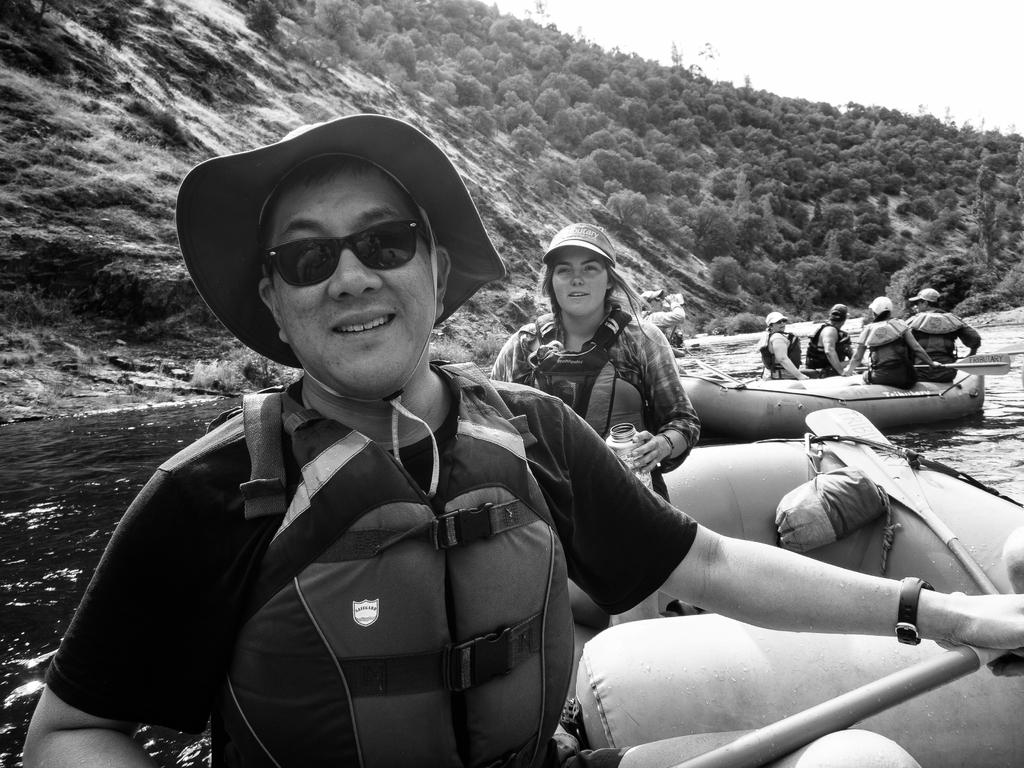What is the color scheme of the image? The image is black and white. What activity is the person in the image engaged in? The person is boating in the image. Where is the person boating? The person is on the surface of a river. What can be seen in the background of the image? There is a hill, trees, and the sky visible in the background of the image. How many sticks does the person have in the image? There are no sticks present in the image. 